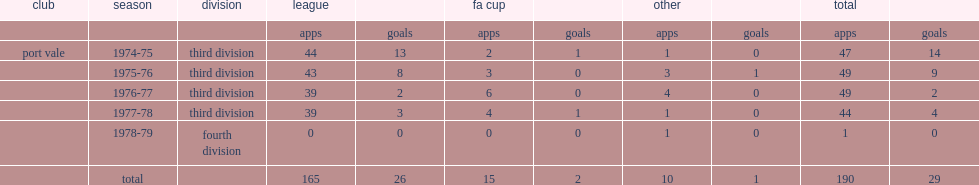How many goals did terry bailey score for vale totally? 29.0. 